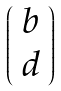<formula> <loc_0><loc_0><loc_500><loc_500>\left ( \begin{array} { c } b \\ d \end{array} \right )</formula> 